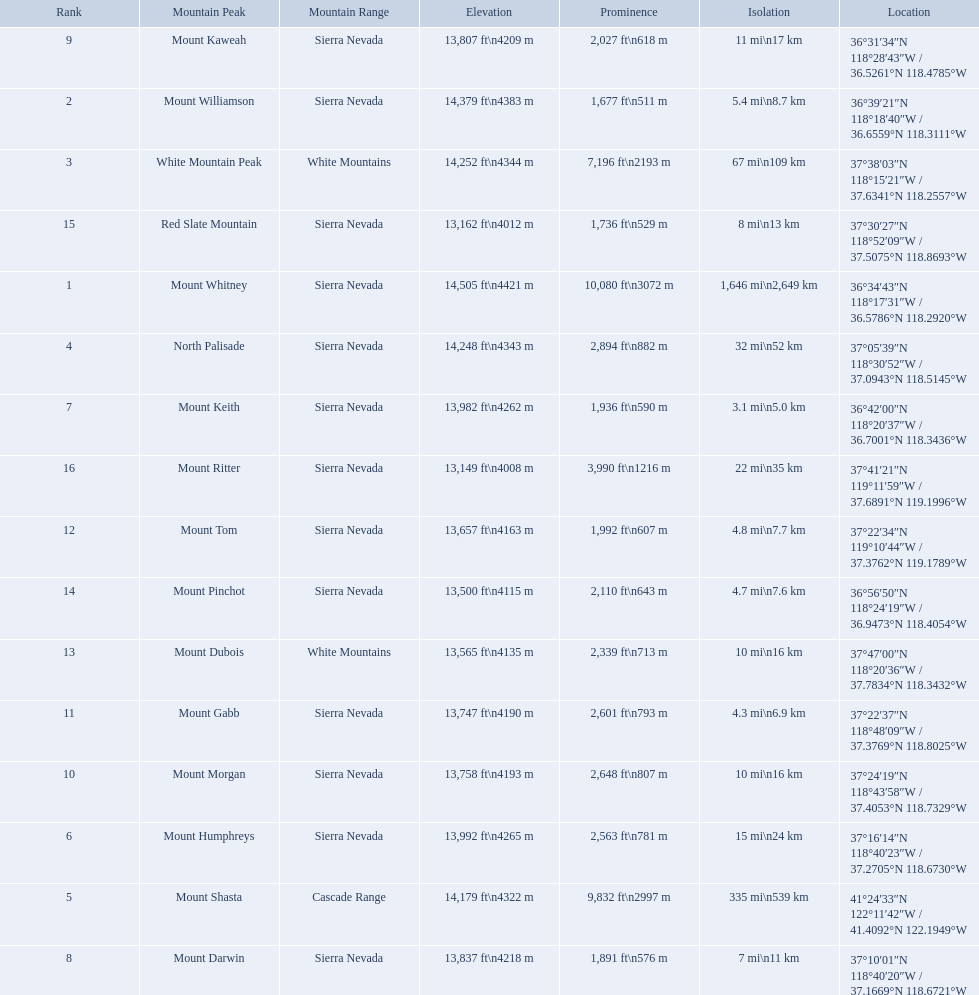What mountain peak is listed for the sierra nevada mountain range? Mount Whitney. What mountain peak has an elevation of 14,379ft? Mount Williamson. Which mountain is listed for the cascade range? Mount Shasta. Write the full table. {'header': ['Rank', 'Mountain Peak', 'Mountain Range', 'Elevation', 'Prominence', 'Isolation', 'Location'], 'rows': [['9', 'Mount Kaweah', 'Sierra Nevada', '13,807\xa0ft\\n4209\xa0m', '2,027\xa0ft\\n618\xa0m', '11\xa0mi\\n17\xa0km', '36°31′34″N 118°28′43″W\ufeff / \ufeff36.5261°N 118.4785°W'], ['2', 'Mount Williamson', 'Sierra Nevada', '14,379\xa0ft\\n4383\xa0m', '1,677\xa0ft\\n511\xa0m', '5.4\xa0mi\\n8.7\xa0km', '36°39′21″N 118°18′40″W\ufeff / \ufeff36.6559°N 118.3111°W'], ['3', 'White Mountain Peak', 'White Mountains', '14,252\xa0ft\\n4344\xa0m', '7,196\xa0ft\\n2193\xa0m', '67\xa0mi\\n109\xa0km', '37°38′03″N 118°15′21″W\ufeff / \ufeff37.6341°N 118.2557°W'], ['15', 'Red Slate Mountain', 'Sierra Nevada', '13,162\xa0ft\\n4012\xa0m', '1,736\xa0ft\\n529\xa0m', '8\xa0mi\\n13\xa0km', '37°30′27″N 118°52′09″W\ufeff / \ufeff37.5075°N 118.8693°W'], ['1', 'Mount Whitney', 'Sierra Nevada', '14,505\xa0ft\\n4421\xa0m', '10,080\xa0ft\\n3072\xa0m', '1,646\xa0mi\\n2,649\xa0km', '36°34′43″N 118°17′31″W\ufeff / \ufeff36.5786°N 118.2920°W'], ['4', 'North Palisade', 'Sierra Nevada', '14,248\xa0ft\\n4343\xa0m', '2,894\xa0ft\\n882\xa0m', '32\xa0mi\\n52\xa0km', '37°05′39″N 118°30′52″W\ufeff / \ufeff37.0943°N 118.5145°W'], ['7', 'Mount Keith', 'Sierra Nevada', '13,982\xa0ft\\n4262\xa0m', '1,936\xa0ft\\n590\xa0m', '3.1\xa0mi\\n5.0\xa0km', '36°42′00″N 118°20′37″W\ufeff / \ufeff36.7001°N 118.3436°W'], ['16', 'Mount Ritter', 'Sierra Nevada', '13,149\xa0ft\\n4008\xa0m', '3,990\xa0ft\\n1216\xa0m', '22\xa0mi\\n35\xa0km', '37°41′21″N 119°11′59″W\ufeff / \ufeff37.6891°N 119.1996°W'], ['12', 'Mount Tom', 'Sierra Nevada', '13,657\xa0ft\\n4163\xa0m', '1,992\xa0ft\\n607\xa0m', '4.8\xa0mi\\n7.7\xa0km', '37°22′34″N 119°10′44″W\ufeff / \ufeff37.3762°N 119.1789°W'], ['14', 'Mount Pinchot', 'Sierra Nevada', '13,500\xa0ft\\n4115\xa0m', '2,110\xa0ft\\n643\xa0m', '4.7\xa0mi\\n7.6\xa0km', '36°56′50″N 118°24′19″W\ufeff / \ufeff36.9473°N 118.4054°W'], ['13', 'Mount Dubois', 'White Mountains', '13,565\xa0ft\\n4135\xa0m', '2,339\xa0ft\\n713\xa0m', '10\xa0mi\\n16\xa0km', '37°47′00″N 118°20′36″W\ufeff / \ufeff37.7834°N 118.3432°W'], ['11', 'Mount Gabb', 'Sierra Nevada', '13,747\xa0ft\\n4190\xa0m', '2,601\xa0ft\\n793\xa0m', '4.3\xa0mi\\n6.9\xa0km', '37°22′37″N 118°48′09″W\ufeff / \ufeff37.3769°N 118.8025°W'], ['10', 'Mount Morgan', 'Sierra Nevada', '13,758\xa0ft\\n4193\xa0m', '2,648\xa0ft\\n807\xa0m', '10\xa0mi\\n16\xa0km', '37°24′19″N 118°43′58″W\ufeff / \ufeff37.4053°N 118.7329°W'], ['6', 'Mount Humphreys', 'Sierra Nevada', '13,992\xa0ft\\n4265\xa0m', '2,563\xa0ft\\n781\xa0m', '15\xa0mi\\n24\xa0km', '37°16′14″N 118°40′23″W\ufeff / \ufeff37.2705°N 118.6730°W'], ['5', 'Mount Shasta', 'Cascade Range', '14,179\xa0ft\\n4322\xa0m', '9,832\xa0ft\\n2997\xa0m', '335\xa0mi\\n539\xa0km', '41°24′33″N 122°11′42″W\ufeff / \ufeff41.4092°N 122.1949°W'], ['8', 'Mount Darwin', 'Sierra Nevada', '13,837\xa0ft\\n4218\xa0m', '1,891\xa0ft\\n576\xa0m', '7\xa0mi\\n11\xa0km', '37°10′01″N 118°40′20″W\ufeff / \ufeff37.1669°N 118.6721°W']]} What are all of the mountain peaks? Mount Whitney, Mount Williamson, White Mountain Peak, North Palisade, Mount Shasta, Mount Humphreys, Mount Keith, Mount Darwin, Mount Kaweah, Mount Morgan, Mount Gabb, Mount Tom, Mount Dubois, Mount Pinchot, Red Slate Mountain, Mount Ritter. In what ranges are they? Sierra Nevada, Sierra Nevada, White Mountains, Sierra Nevada, Cascade Range, Sierra Nevada, Sierra Nevada, Sierra Nevada, Sierra Nevada, Sierra Nevada, Sierra Nevada, Sierra Nevada, White Mountains, Sierra Nevada, Sierra Nevada, Sierra Nevada. Which peak is in the cascade range? Mount Shasta. 